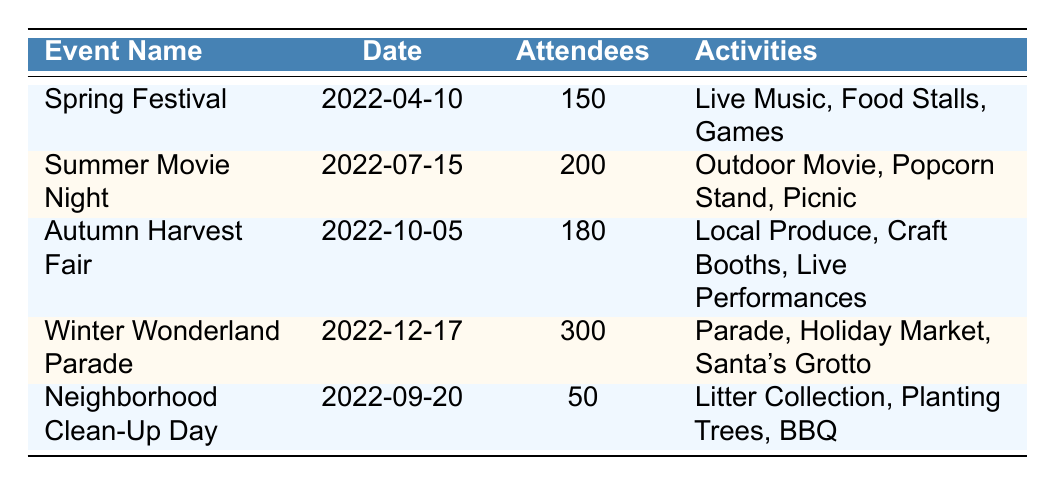What is the total number of attendees for all the events? To find the total number of attendees, we sum the attendees of each event: 150 (Spring Festival) + 200 (Summer Movie Night) + 180 (Autumn Harvest Fair) + 300 (Winter Wonderland Parade) + 50 (Neighborhood Clean-Up Day) = 1080.
Answer: 1080 Which event had the highest attendance? From the table, we see that the Winter Wonderland Parade has 300 attendees, which is the highest compared to the other events listed.
Answer: Winter Wonderland Parade How many events were held in the summer? The Summer Movie Night is the only event listed in July, making it the sole summer event.
Answer: 1 Is the Autumn Harvest Fair attended by more people than the Spring Festival? The Autumn Harvest Fair has 180 attendees, while the Spring Festival has 150 attendees. Since 180 is greater than 150, the statement is true.
Answer: Yes What is the average number of attendees per event? To calculate the average, we take the total number of attendees (1080) and divide by the number of events (5). Thus, 1080 ÷ 5 = 216.
Answer: 216 Did the Neighborhood Clean-Up Day have more attendees than the Spring Festival? The Neighborhood Clean-Up Day had 50 attendees, while the Spring Festival had 150 attendees. Since 50 is less than 150, the statement is false.
Answer: No What was the main location for the Winter Wonderland Parade? The table indicates that the Winter Wonderland Parade took place on Main Street, which is its main location.
Answer: Main Street Which events included activities related to food? The Spring Festival has food stalls, the Summer Movie Night has a popcorn stand, and the Winter Wonderland Parade includes a holiday market. Therefore, these three events are involved with food-related activities.
Answer: Spring Festival, Summer Movie Night, Winter Wonderland Parade 